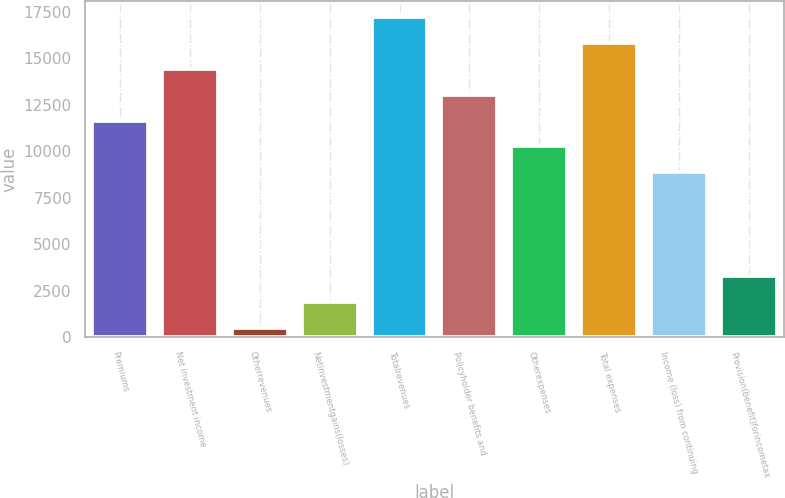Convert chart to OTSL. <chart><loc_0><loc_0><loc_500><loc_500><bar_chart><fcel>Premiums<fcel>Net investment income<fcel>Otherrevenues<fcel>Netinvestmentgains(losses)<fcel>Totalrevenues<fcel>Policyholder benefits and<fcel>Otherexpenses<fcel>Total expenses<fcel>Income (loss) from continuing<fcel>Provision(benefit)forincometax<nl><fcel>11648<fcel>14429<fcel>524<fcel>1914.5<fcel>17210<fcel>13038.5<fcel>10257.5<fcel>15819.5<fcel>8867<fcel>3305<nl></chart> 